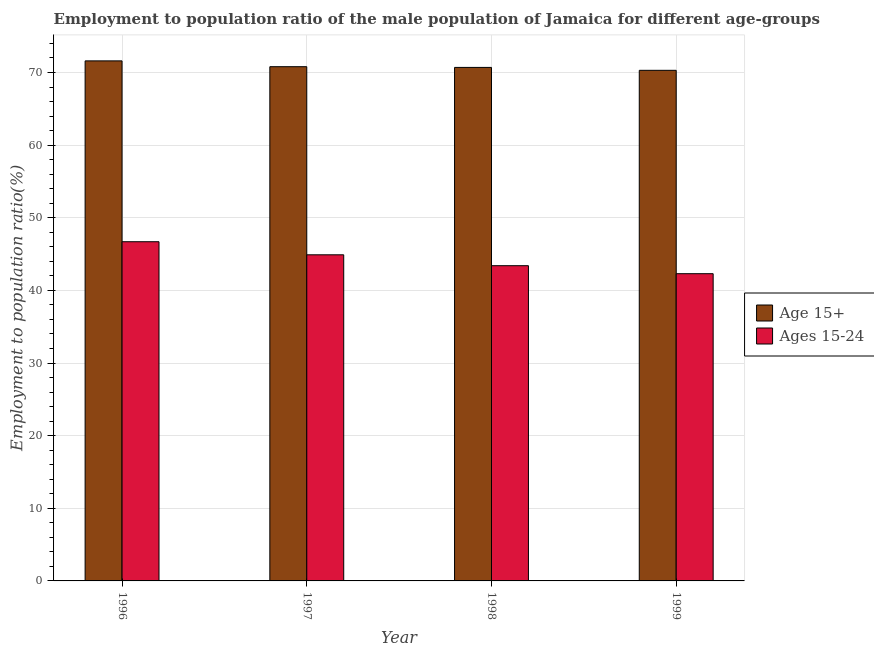How many different coloured bars are there?
Ensure brevity in your answer.  2. How many groups of bars are there?
Ensure brevity in your answer.  4. How many bars are there on the 3rd tick from the right?
Ensure brevity in your answer.  2. What is the label of the 1st group of bars from the left?
Provide a short and direct response. 1996. What is the employment to population ratio(age 15-24) in 1999?
Ensure brevity in your answer.  42.3. Across all years, what is the maximum employment to population ratio(age 15+)?
Offer a terse response. 71.6. Across all years, what is the minimum employment to population ratio(age 15+)?
Offer a very short reply. 70.3. What is the total employment to population ratio(age 15+) in the graph?
Provide a succinct answer. 283.4. What is the difference between the employment to population ratio(age 15+) in 1996 and that in 1998?
Provide a short and direct response. 0.9. What is the difference between the employment to population ratio(age 15-24) in 1998 and the employment to population ratio(age 15+) in 1996?
Your response must be concise. -3.3. What is the average employment to population ratio(age 15+) per year?
Give a very brief answer. 70.85. In how many years, is the employment to population ratio(age 15+) greater than 16 %?
Your response must be concise. 4. What is the ratio of the employment to population ratio(age 15-24) in 1997 to that in 1999?
Offer a very short reply. 1.06. Is the difference between the employment to population ratio(age 15+) in 1998 and 1999 greater than the difference between the employment to population ratio(age 15-24) in 1998 and 1999?
Ensure brevity in your answer.  No. What is the difference between the highest and the second highest employment to population ratio(age 15-24)?
Provide a short and direct response. 1.8. What is the difference between the highest and the lowest employment to population ratio(age 15+)?
Make the answer very short. 1.3. What does the 1st bar from the left in 1996 represents?
Offer a very short reply. Age 15+. What does the 2nd bar from the right in 1997 represents?
Your answer should be very brief. Age 15+. Are the values on the major ticks of Y-axis written in scientific E-notation?
Provide a short and direct response. No. Does the graph contain any zero values?
Keep it short and to the point. No. Does the graph contain grids?
Offer a terse response. Yes. Where does the legend appear in the graph?
Your answer should be very brief. Center right. How many legend labels are there?
Make the answer very short. 2. What is the title of the graph?
Your answer should be very brief. Employment to population ratio of the male population of Jamaica for different age-groups. Does "Measles" appear as one of the legend labels in the graph?
Provide a short and direct response. No. What is the label or title of the X-axis?
Your answer should be compact. Year. What is the label or title of the Y-axis?
Your answer should be compact. Employment to population ratio(%). What is the Employment to population ratio(%) in Age 15+ in 1996?
Your response must be concise. 71.6. What is the Employment to population ratio(%) of Ages 15-24 in 1996?
Your answer should be compact. 46.7. What is the Employment to population ratio(%) of Age 15+ in 1997?
Your response must be concise. 70.8. What is the Employment to population ratio(%) in Ages 15-24 in 1997?
Provide a short and direct response. 44.9. What is the Employment to population ratio(%) of Age 15+ in 1998?
Provide a short and direct response. 70.7. What is the Employment to population ratio(%) in Ages 15-24 in 1998?
Your response must be concise. 43.4. What is the Employment to population ratio(%) of Age 15+ in 1999?
Ensure brevity in your answer.  70.3. What is the Employment to population ratio(%) of Ages 15-24 in 1999?
Give a very brief answer. 42.3. Across all years, what is the maximum Employment to population ratio(%) in Age 15+?
Ensure brevity in your answer.  71.6. Across all years, what is the maximum Employment to population ratio(%) in Ages 15-24?
Provide a succinct answer. 46.7. Across all years, what is the minimum Employment to population ratio(%) in Age 15+?
Keep it short and to the point. 70.3. Across all years, what is the minimum Employment to population ratio(%) of Ages 15-24?
Provide a succinct answer. 42.3. What is the total Employment to population ratio(%) in Age 15+ in the graph?
Give a very brief answer. 283.4. What is the total Employment to population ratio(%) in Ages 15-24 in the graph?
Give a very brief answer. 177.3. What is the difference between the Employment to population ratio(%) of Age 15+ in 1996 and that in 1997?
Make the answer very short. 0.8. What is the difference between the Employment to population ratio(%) in Age 15+ in 1996 and that in 1998?
Provide a succinct answer. 0.9. What is the difference between the Employment to population ratio(%) in Age 15+ in 1996 and that in 1999?
Your answer should be compact. 1.3. What is the difference between the Employment to population ratio(%) of Age 15+ in 1997 and that in 1998?
Make the answer very short. 0.1. What is the difference between the Employment to population ratio(%) of Ages 15-24 in 1997 and that in 1998?
Your answer should be compact. 1.5. What is the difference between the Employment to population ratio(%) in Ages 15-24 in 1998 and that in 1999?
Your response must be concise. 1.1. What is the difference between the Employment to population ratio(%) in Age 15+ in 1996 and the Employment to population ratio(%) in Ages 15-24 in 1997?
Give a very brief answer. 26.7. What is the difference between the Employment to population ratio(%) of Age 15+ in 1996 and the Employment to population ratio(%) of Ages 15-24 in 1998?
Make the answer very short. 28.2. What is the difference between the Employment to population ratio(%) of Age 15+ in 1996 and the Employment to population ratio(%) of Ages 15-24 in 1999?
Ensure brevity in your answer.  29.3. What is the difference between the Employment to population ratio(%) of Age 15+ in 1997 and the Employment to population ratio(%) of Ages 15-24 in 1998?
Provide a succinct answer. 27.4. What is the difference between the Employment to population ratio(%) in Age 15+ in 1998 and the Employment to population ratio(%) in Ages 15-24 in 1999?
Offer a very short reply. 28.4. What is the average Employment to population ratio(%) in Age 15+ per year?
Give a very brief answer. 70.85. What is the average Employment to population ratio(%) of Ages 15-24 per year?
Ensure brevity in your answer.  44.33. In the year 1996, what is the difference between the Employment to population ratio(%) in Age 15+ and Employment to population ratio(%) in Ages 15-24?
Offer a very short reply. 24.9. In the year 1997, what is the difference between the Employment to population ratio(%) in Age 15+ and Employment to population ratio(%) in Ages 15-24?
Provide a short and direct response. 25.9. In the year 1998, what is the difference between the Employment to population ratio(%) in Age 15+ and Employment to population ratio(%) in Ages 15-24?
Your response must be concise. 27.3. What is the ratio of the Employment to population ratio(%) of Age 15+ in 1996 to that in 1997?
Offer a very short reply. 1.01. What is the ratio of the Employment to population ratio(%) of Ages 15-24 in 1996 to that in 1997?
Provide a short and direct response. 1.04. What is the ratio of the Employment to population ratio(%) of Age 15+ in 1996 to that in 1998?
Your answer should be very brief. 1.01. What is the ratio of the Employment to population ratio(%) in Ages 15-24 in 1996 to that in 1998?
Offer a very short reply. 1.08. What is the ratio of the Employment to population ratio(%) of Age 15+ in 1996 to that in 1999?
Your response must be concise. 1.02. What is the ratio of the Employment to population ratio(%) of Ages 15-24 in 1996 to that in 1999?
Keep it short and to the point. 1.1. What is the ratio of the Employment to population ratio(%) of Ages 15-24 in 1997 to that in 1998?
Your response must be concise. 1.03. What is the ratio of the Employment to population ratio(%) of Age 15+ in 1997 to that in 1999?
Keep it short and to the point. 1.01. What is the ratio of the Employment to population ratio(%) in Ages 15-24 in 1997 to that in 1999?
Your answer should be very brief. 1.06. What is the ratio of the Employment to population ratio(%) in Ages 15-24 in 1998 to that in 1999?
Offer a terse response. 1.03. What is the difference between the highest and the second highest Employment to population ratio(%) in Age 15+?
Provide a short and direct response. 0.8. What is the difference between the highest and the lowest Employment to population ratio(%) of Ages 15-24?
Provide a succinct answer. 4.4. 